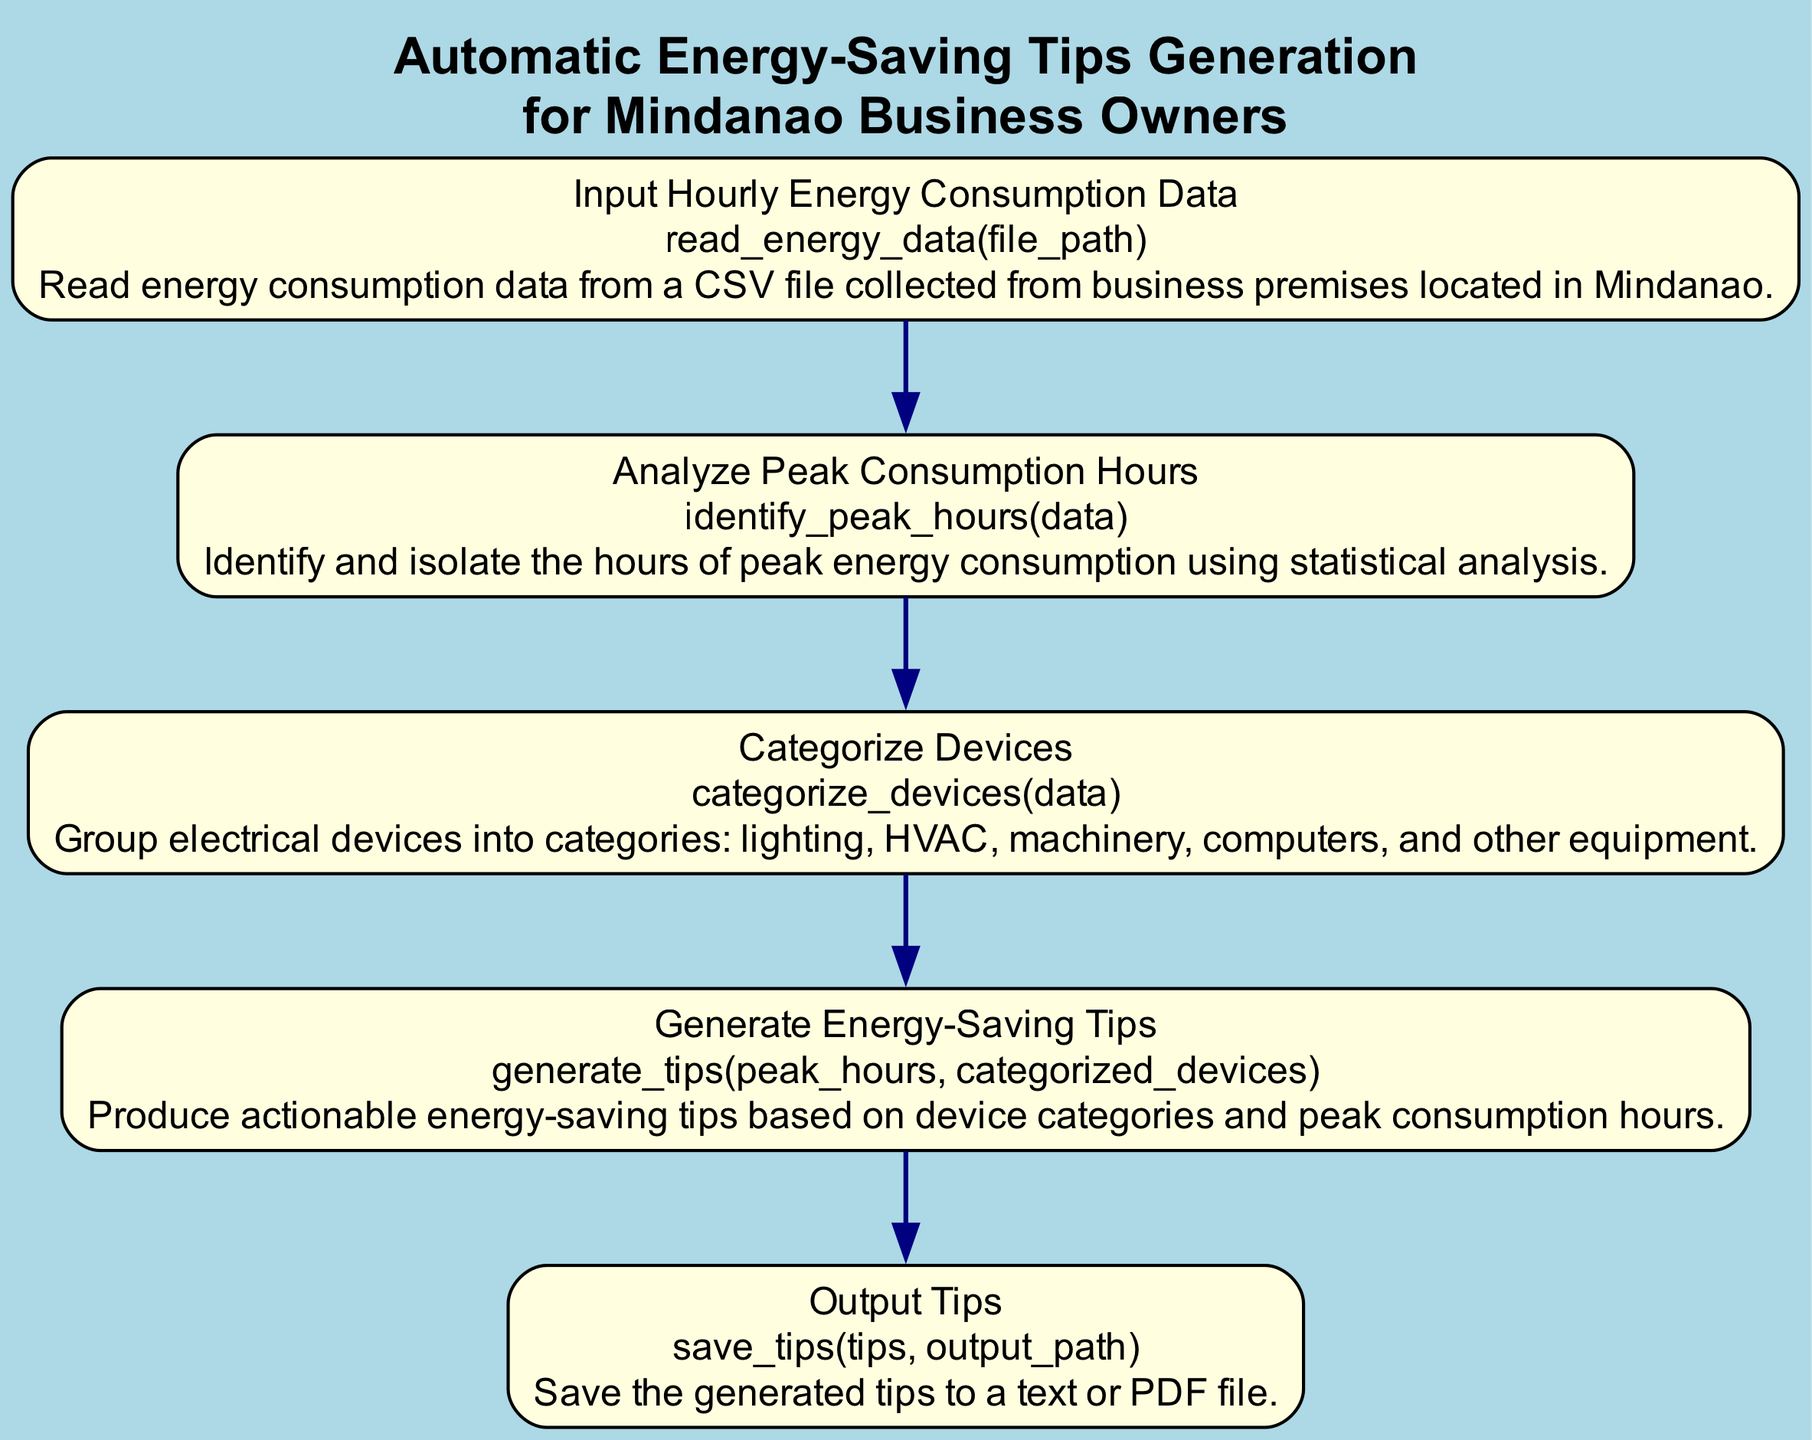What is the first step in the flowchart? The first step in the flowchart is "Input Hourly Energy Consumption Data," which involves reading energy consumption data from a CSV file.
Answer: Input Hourly Energy Consumption Data How many nodes are in the flowchart? The flowchart has five nodes, each representing a specific function in the energy-saving tips generation process.
Answer: Five What is the function associated with "Categorize Devices"? The function associated with "Categorize Devices" is "categorize_devices(data)." This function groups electrical devices into categories.
Answer: categorize_devices(data) What follows "Analyze Peak Consumption Hours"? "Generate Energy-Saving Tips" follows "Analyze Peak Consumption Hours" in the flowchart, indicating the sequence of actions taken after identifying peak consumption hours.
Answer: Generate Energy-Saving Tips Which node saves the generated tips? The node that saves the generated tips is "Output Tips," associated with the function "save_tips(tips, output_path)." This node outputs the tips to a file.
Answer: Output Tips Which two nodes are directly connected? The nodes "Input Hourly Energy Consumption Data" and "Analyze Peak Consumption Hours" are directly connected, indicating that the output of the first node is the input for the second.
Answer: Input Hourly Energy Consumption Data and Analyze Peak Consumption Hours What is the main purpose of the flowchart? The main purpose of the flowchart is to provide a structured approach for generating automatic energy-saving tips specifically for businesses in Mindanao.
Answer: Generate energy-saving tips How does "Generate Energy-Saving Tips" relate to peak hours and categorized devices? "Generate Energy-Saving Tips" is based on analyzing both the peak consumption hours identified earlier and the categorized devices, making it reliant on both sets of data for effective tip generation.
Answer: Based on peak hours and categorized devices What descriptive title does the flowchart have? The descriptive title of the flowchart is "Automatic Energy-Saving Tips Generation for Mindanao Business Owners," clearly indicating its purpose and target audience.
Answer: Automatic Energy-Saving Tips Generation for Mindanao Business Owners 